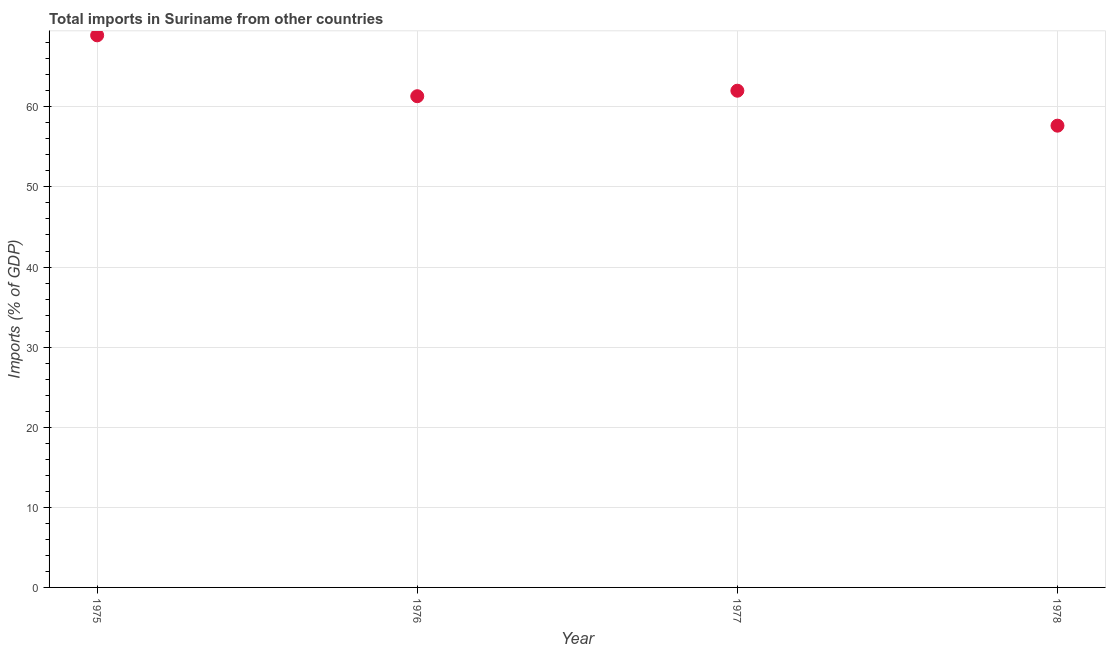What is the total imports in 1976?
Your response must be concise. 61.33. Across all years, what is the maximum total imports?
Provide a succinct answer. 68.92. Across all years, what is the minimum total imports?
Your answer should be very brief. 57.65. In which year was the total imports maximum?
Your answer should be very brief. 1975. In which year was the total imports minimum?
Your answer should be compact. 1978. What is the sum of the total imports?
Offer a terse response. 249.91. What is the difference between the total imports in 1976 and 1977?
Your answer should be very brief. -0.69. What is the average total imports per year?
Your answer should be very brief. 62.48. What is the median total imports?
Your response must be concise. 61.67. In how many years, is the total imports greater than 28 %?
Offer a very short reply. 4. Do a majority of the years between 1978 and 1976 (inclusive) have total imports greater than 54 %?
Your answer should be compact. No. What is the ratio of the total imports in 1977 to that in 1978?
Make the answer very short. 1.08. What is the difference between the highest and the second highest total imports?
Offer a terse response. 6.91. What is the difference between the highest and the lowest total imports?
Ensure brevity in your answer.  11.28. In how many years, is the total imports greater than the average total imports taken over all years?
Your answer should be compact. 1. How many dotlines are there?
Provide a succinct answer. 1. What is the title of the graph?
Keep it short and to the point. Total imports in Suriname from other countries. What is the label or title of the X-axis?
Make the answer very short. Year. What is the label or title of the Y-axis?
Your answer should be compact. Imports (% of GDP). What is the Imports (% of GDP) in 1975?
Make the answer very short. 68.92. What is the Imports (% of GDP) in 1976?
Make the answer very short. 61.33. What is the Imports (% of GDP) in 1977?
Provide a short and direct response. 62.01. What is the Imports (% of GDP) in 1978?
Provide a succinct answer. 57.65. What is the difference between the Imports (% of GDP) in 1975 and 1976?
Offer a terse response. 7.6. What is the difference between the Imports (% of GDP) in 1975 and 1977?
Your answer should be very brief. 6.91. What is the difference between the Imports (% of GDP) in 1975 and 1978?
Your response must be concise. 11.28. What is the difference between the Imports (% of GDP) in 1976 and 1977?
Your answer should be very brief. -0.69. What is the difference between the Imports (% of GDP) in 1976 and 1978?
Provide a succinct answer. 3.68. What is the difference between the Imports (% of GDP) in 1977 and 1978?
Your response must be concise. 4.36. What is the ratio of the Imports (% of GDP) in 1975 to that in 1976?
Your response must be concise. 1.12. What is the ratio of the Imports (% of GDP) in 1975 to that in 1977?
Make the answer very short. 1.11. What is the ratio of the Imports (% of GDP) in 1975 to that in 1978?
Provide a short and direct response. 1.2. What is the ratio of the Imports (% of GDP) in 1976 to that in 1977?
Ensure brevity in your answer.  0.99. What is the ratio of the Imports (% of GDP) in 1976 to that in 1978?
Make the answer very short. 1.06. What is the ratio of the Imports (% of GDP) in 1977 to that in 1978?
Provide a short and direct response. 1.08. 